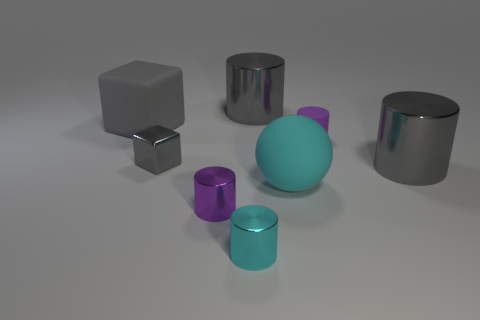Is the number of small cyan objects behind the small cyan cylinder greater than the number of tiny yellow matte spheres?
Your response must be concise. No. Is there a large metal ball?
Provide a short and direct response. No. How many matte things have the same size as the rubber sphere?
Your answer should be very brief. 1. Are there more tiny cyan metallic cylinders that are right of the small cyan cylinder than large balls that are behind the small gray metallic cube?
Your answer should be very brief. No. What is the material of the sphere that is the same size as the rubber cube?
Give a very brief answer. Rubber. What is the shape of the small matte object?
Provide a short and direct response. Cylinder. How many cyan objects are small metal spheres or balls?
Give a very brief answer. 1. There is a purple cylinder that is made of the same material as the small cyan cylinder; what is its size?
Offer a terse response. Small. Do the small purple cylinder that is left of the purple matte object and the large gray cylinder that is on the right side of the cyan ball have the same material?
Ensure brevity in your answer.  Yes. How many cylinders are tiny yellow matte objects or tiny gray objects?
Offer a terse response. 0. 